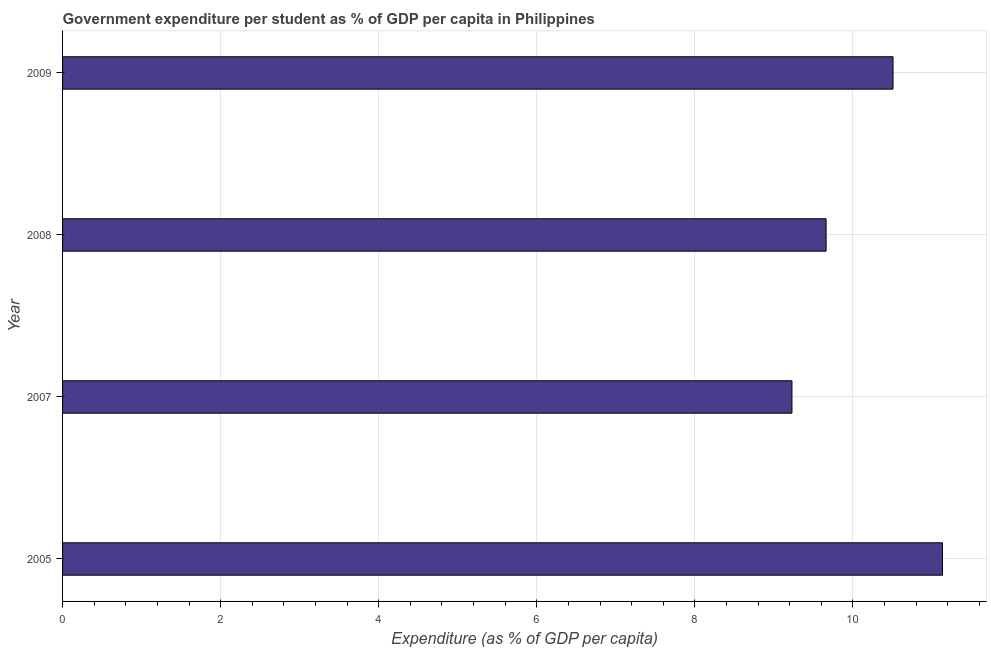Does the graph contain any zero values?
Give a very brief answer. No. Does the graph contain grids?
Offer a terse response. Yes. What is the title of the graph?
Keep it short and to the point. Government expenditure per student as % of GDP per capita in Philippines. What is the label or title of the X-axis?
Ensure brevity in your answer.  Expenditure (as % of GDP per capita). What is the government expenditure per student in 2008?
Offer a terse response. 9.66. Across all years, what is the maximum government expenditure per student?
Keep it short and to the point. 11.13. Across all years, what is the minimum government expenditure per student?
Keep it short and to the point. 9.23. What is the sum of the government expenditure per student?
Provide a succinct answer. 40.53. What is the difference between the government expenditure per student in 2005 and 2008?
Your answer should be very brief. 1.47. What is the average government expenditure per student per year?
Your answer should be very brief. 10.13. What is the median government expenditure per student?
Your answer should be very brief. 10.08. Do a majority of the years between 2008 and 2009 (inclusive) have government expenditure per student greater than 9.6 %?
Offer a terse response. Yes. What is the ratio of the government expenditure per student in 2007 to that in 2008?
Provide a succinct answer. 0.95. Is the difference between the government expenditure per student in 2005 and 2007 greater than the difference between any two years?
Offer a very short reply. Yes. What is the difference between the highest and the second highest government expenditure per student?
Your answer should be very brief. 0.63. How many bars are there?
Offer a terse response. 4. Are all the bars in the graph horizontal?
Your response must be concise. Yes. How many years are there in the graph?
Give a very brief answer. 4. What is the difference between two consecutive major ticks on the X-axis?
Your response must be concise. 2. Are the values on the major ticks of X-axis written in scientific E-notation?
Ensure brevity in your answer.  No. What is the Expenditure (as % of GDP per capita) in 2005?
Keep it short and to the point. 11.13. What is the Expenditure (as % of GDP per capita) in 2007?
Provide a short and direct response. 9.23. What is the Expenditure (as % of GDP per capita) of 2008?
Keep it short and to the point. 9.66. What is the Expenditure (as % of GDP per capita) in 2009?
Make the answer very short. 10.51. What is the difference between the Expenditure (as % of GDP per capita) in 2005 and 2007?
Your answer should be very brief. 1.9. What is the difference between the Expenditure (as % of GDP per capita) in 2005 and 2008?
Your response must be concise. 1.47. What is the difference between the Expenditure (as % of GDP per capita) in 2005 and 2009?
Ensure brevity in your answer.  0.63. What is the difference between the Expenditure (as % of GDP per capita) in 2007 and 2008?
Offer a terse response. -0.43. What is the difference between the Expenditure (as % of GDP per capita) in 2007 and 2009?
Ensure brevity in your answer.  -1.28. What is the difference between the Expenditure (as % of GDP per capita) in 2008 and 2009?
Your response must be concise. -0.85. What is the ratio of the Expenditure (as % of GDP per capita) in 2005 to that in 2007?
Provide a succinct answer. 1.21. What is the ratio of the Expenditure (as % of GDP per capita) in 2005 to that in 2008?
Provide a short and direct response. 1.15. What is the ratio of the Expenditure (as % of GDP per capita) in 2005 to that in 2009?
Your response must be concise. 1.06. What is the ratio of the Expenditure (as % of GDP per capita) in 2007 to that in 2008?
Your answer should be compact. 0.95. What is the ratio of the Expenditure (as % of GDP per capita) in 2007 to that in 2009?
Offer a very short reply. 0.88. What is the ratio of the Expenditure (as % of GDP per capita) in 2008 to that in 2009?
Offer a terse response. 0.92. 